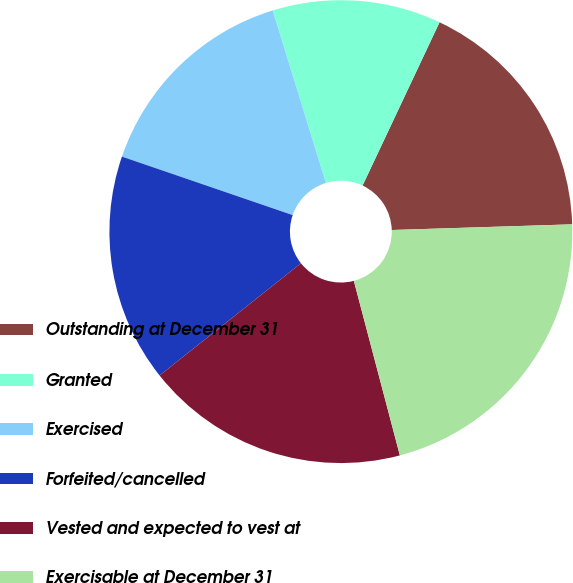Convert chart. <chart><loc_0><loc_0><loc_500><loc_500><pie_chart><fcel>Outstanding at December 31<fcel>Granted<fcel>Exercised<fcel>Forfeited/cancelled<fcel>Vested and expected to vest at<fcel>Exercisable at December 31<nl><fcel>17.49%<fcel>11.77%<fcel>14.99%<fcel>15.93%<fcel>18.43%<fcel>21.4%<nl></chart> 